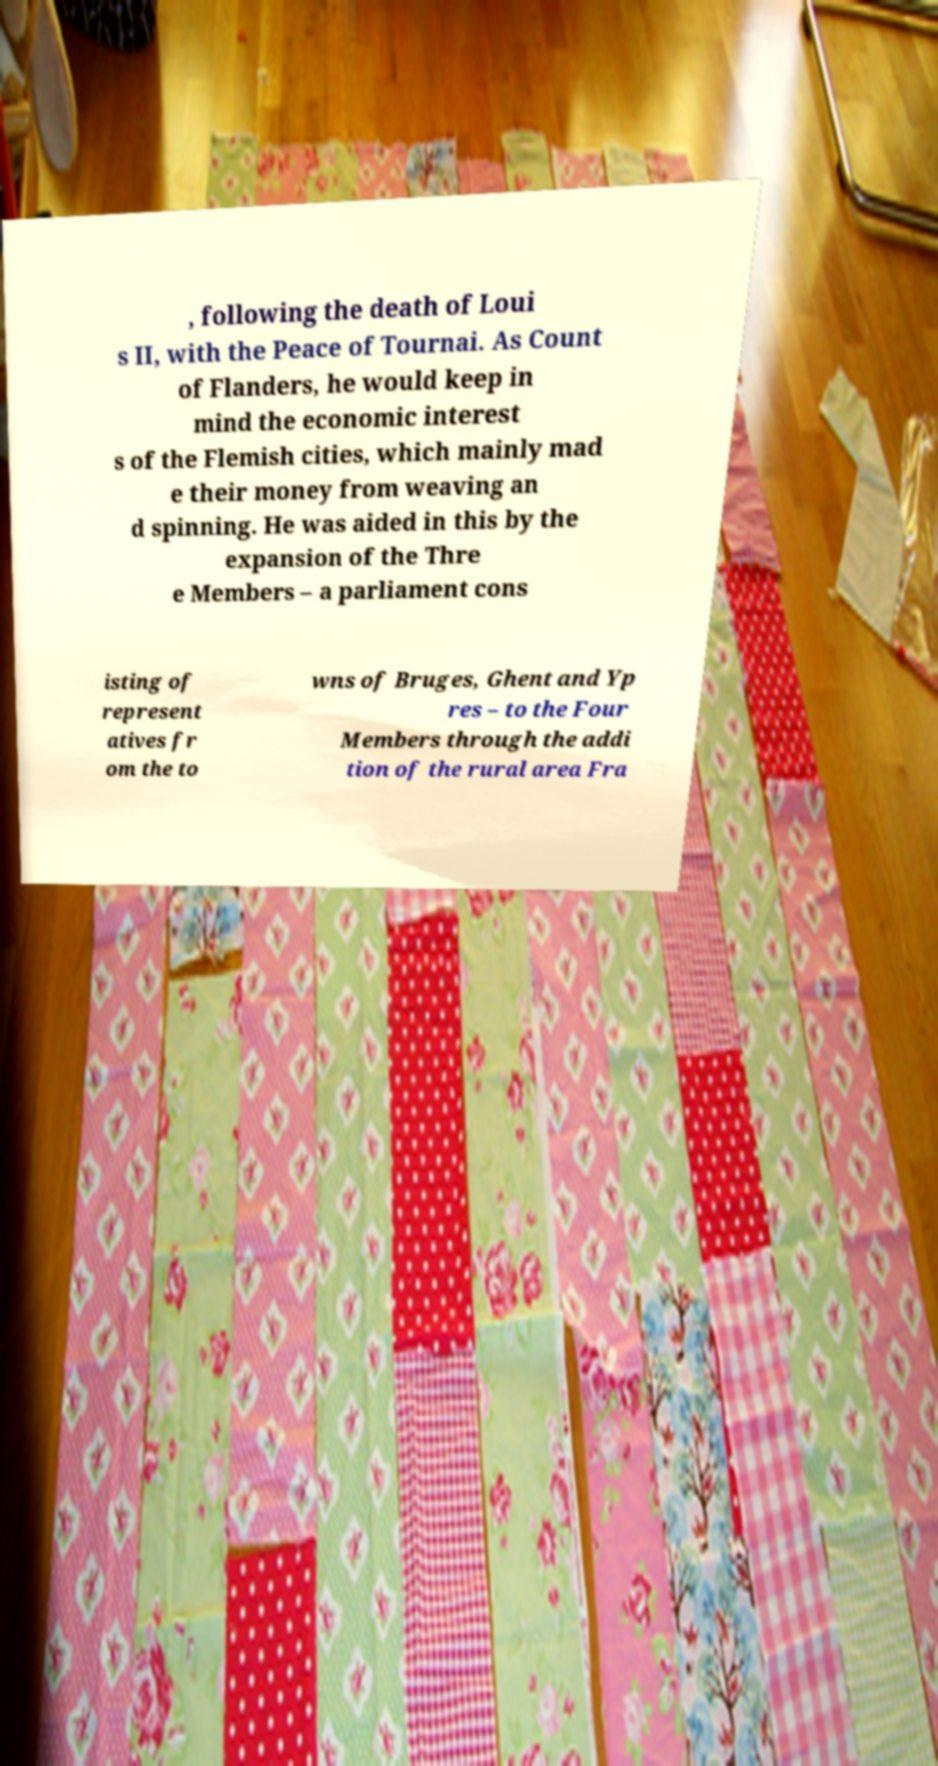Please read and relay the text visible in this image. What does it say? , following the death of Loui s II, with the Peace of Tournai. As Count of Flanders, he would keep in mind the economic interest s of the Flemish cities, which mainly mad e their money from weaving an d spinning. He was aided in this by the expansion of the Thre e Members – a parliament cons isting of represent atives fr om the to wns of Bruges, Ghent and Yp res – to the Four Members through the addi tion of the rural area Fra 